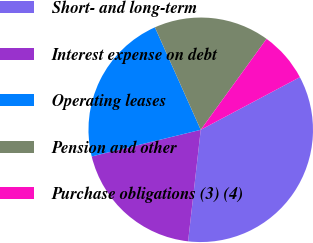Convert chart to OTSL. <chart><loc_0><loc_0><loc_500><loc_500><pie_chart><fcel>Short- and long-term<fcel>Interest expense on debt<fcel>Operating leases<fcel>Pension and other<fcel>Purchase obligations (3) (4)<nl><fcel>34.56%<fcel>19.39%<fcel>22.12%<fcel>16.66%<fcel>7.26%<nl></chart> 